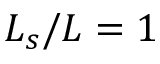<formula> <loc_0><loc_0><loc_500><loc_500>L _ { s } / L = 1</formula> 